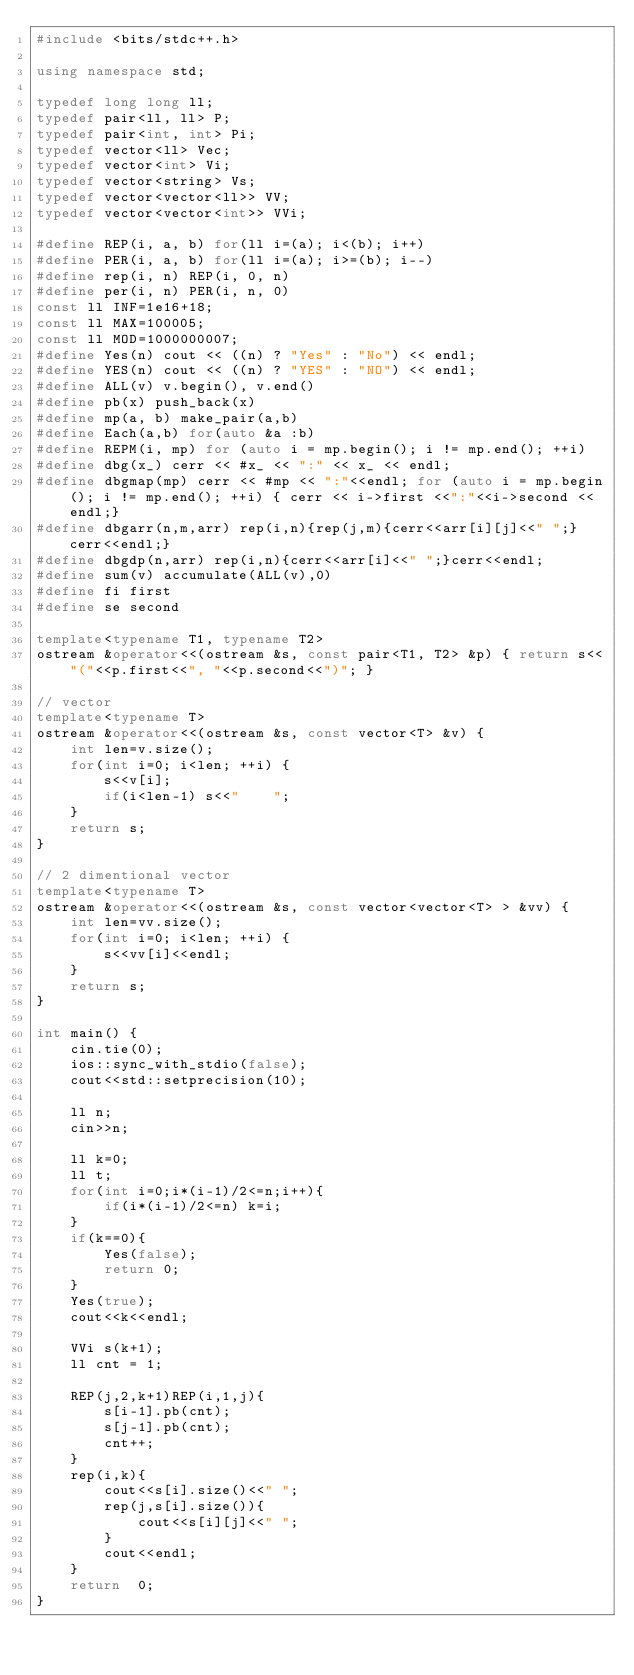<code> <loc_0><loc_0><loc_500><loc_500><_C++_>#include <bits/stdc++.h>

using namespace std;

typedef long long ll;
typedef pair<ll, ll> P;
typedef pair<int, int> Pi;
typedef vector<ll> Vec;
typedef vector<int> Vi;
typedef vector<string> Vs;
typedef vector<vector<ll>> VV;
typedef vector<vector<int>> VVi;

#define REP(i, a, b) for(ll i=(a); i<(b); i++)
#define PER(i, a, b) for(ll i=(a); i>=(b); i--)
#define rep(i, n) REP(i, 0, n)
#define per(i, n) PER(i, n, 0)
const ll INF=1e16+18;
const ll MAX=100005;
const ll MOD=1000000007;
#define Yes(n) cout << ((n) ? "Yes" : "No") << endl;
#define YES(n) cout << ((n) ? "YES" : "NO") << endl;
#define ALL(v) v.begin(), v.end()
#define pb(x) push_back(x)
#define mp(a, b) make_pair(a,b)
#define Each(a,b) for(auto &a :b)
#define REPM(i, mp) for (auto i = mp.begin(); i != mp.end(); ++i)
#define dbg(x_) cerr << #x_ << ":" << x_ << endl;
#define dbgmap(mp) cerr << #mp << ":"<<endl; for (auto i = mp.begin(); i != mp.end(); ++i) { cerr << i->first <<":"<<i->second << endl;}
#define dbgarr(n,m,arr) rep(i,n){rep(j,m){cerr<<arr[i][j]<<" ";}cerr<<endl;}
#define dbgdp(n,arr) rep(i,n){cerr<<arr[i]<<" ";}cerr<<endl;
#define sum(v) accumulate(ALL(v),0)
#define fi first
#define se second

template<typename T1, typename T2>
ostream &operator<<(ostream &s, const pair<T1, T2> &p) { return s<<"("<<p.first<<", "<<p.second<<")"; }

// vector
template<typename T>
ostream &operator<<(ostream &s, const vector<T> &v) {
    int len=v.size();
    for(int i=0; i<len; ++i) {
        s<<v[i];
        if(i<len-1) s<<"	";
    }
    return s;
}

// 2 dimentional vector
template<typename T>
ostream &operator<<(ostream &s, const vector<vector<T> > &vv) {
    int len=vv.size();
    for(int i=0; i<len; ++i) {
        s<<vv[i]<<endl;
    }
    return s;
}

int main() {
    cin.tie(0);
    ios::sync_with_stdio(false);
    cout<<std::setprecision(10);

    ll n;
    cin>>n;

    ll k=0;
    ll t;
    for(int i=0;i*(i-1)/2<=n;i++){
        if(i*(i-1)/2<=n) k=i;
    }
    if(k==0){
        Yes(false);
        return 0;
    }
    Yes(true);
    cout<<k<<endl;

    VVi s(k+1);
    ll cnt = 1;

    REP(j,2,k+1)REP(i,1,j){
        s[i-1].pb(cnt);
        s[j-1].pb(cnt);
        cnt++;
    }
    rep(i,k){
        cout<<s[i].size()<<" ";
        rep(j,s[i].size()){
            cout<<s[i][j]<<" ";
        }
        cout<<endl;
    }
    return  0;
}
</code> 